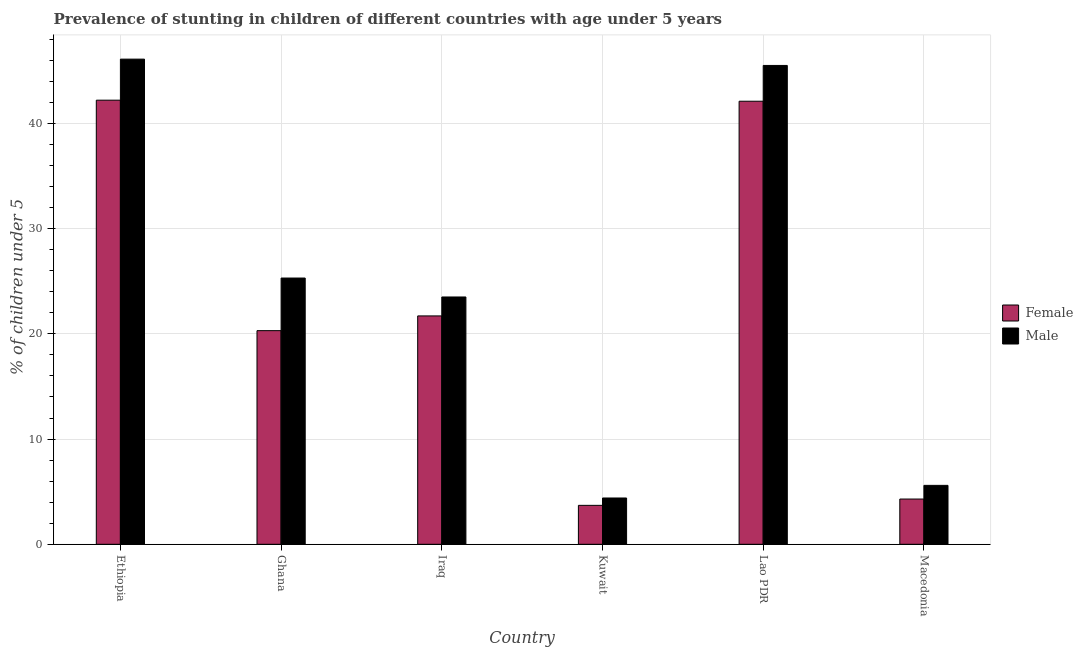How many different coloured bars are there?
Provide a short and direct response. 2. How many groups of bars are there?
Your answer should be very brief. 6. Are the number of bars per tick equal to the number of legend labels?
Your answer should be compact. Yes. Are the number of bars on each tick of the X-axis equal?
Your answer should be compact. Yes. How many bars are there on the 1st tick from the right?
Your answer should be very brief. 2. What is the percentage of stunted female children in Macedonia?
Give a very brief answer. 4.3. Across all countries, what is the maximum percentage of stunted male children?
Keep it short and to the point. 46.1. Across all countries, what is the minimum percentage of stunted female children?
Provide a short and direct response. 3.7. In which country was the percentage of stunted female children maximum?
Ensure brevity in your answer.  Ethiopia. In which country was the percentage of stunted female children minimum?
Give a very brief answer. Kuwait. What is the total percentage of stunted female children in the graph?
Ensure brevity in your answer.  134.3. What is the difference between the percentage of stunted male children in Ethiopia and that in Lao PDR?
Provide a succinct answer. 0.6. What is the difference between the percentage of stunted female children in Ghana and the percentage of stunted male children in Lao PDR?
Give a very brief answer. -25.2. What is the average percentage of stunted female children per country?
Keep it short and to the point. 22.38. What is the difference between the percentage of stunted male children and percentage of stunted female children in Iraq?
Offer a terse response. 1.8. In how many countries, is the percentage of stunted female children greater than 32 %?
Give a very brief answer. 2. What is the ratio of the percentage of stunted female children in Ethiopia to that in Kuwait?
Provide a succinct answer. 11.41. Is the difference between the percentage of stunted male children in Ethiopia and Macedonia greater than the difference between the percentage of stunted female children in Ethiopia and Macedonia?
Your answer should be very brief. Yes. What is the difference between the highest and the second highest percentage of stunted female children?
Your answer should be compact. 0.1. What is the difference between the highest and the lowest percentage of stunted female children?
Your answer should be very brief. 38.5. In how many countries, is the percentage of stunted female children greater than the average percentage of stunted female children taken over all countries?
Offer a very short reply. 2. Is the sum of the percentage of stunted male children in Ethiopia and Lao PDR greater than the maximum percentage of stunted female children across all countries?
Make the answer very short. Yes. What does the 1st bar from the right in Ghana represents?
Offer a very short reply. Male. How many bars are there?
Your answer should be compact. 12. What is the difference between two consecutive major ticks on the Y-axis?
Provide a succinct answer. 10. Does the graph contain any zero values?
Offer a terse response. No. Does the graph contain grids?
Your response must be concise. Yes. Where does the legend appear in the graph?
Keep it short and to the point. Center right. How many legend labels are there?
Give a very brief answer. 2. How are the legend labels stacked?
Provide a succinct answer. Vertical. What is the title of the graph?
Offer a very short reply. Prevalence of stunting in children of different countries with age under 5 years. Does "Lowest 10% of population" appear as one of the legend labels in the graph?
Give a very brief answer. No. What is the label or title of the Y-axis?
Your answer should be compact.  % of children under 5. What is the  % of children under 5 in Female in Ethiopia?
Offer a very short reply. 42.2. What is the  % of children under 5 of Male in Ethiopia?
Your response must be concise. 46.1. What is the  % of children under 5 of Female in Ghana?
Ensure brevity in your answer.  20.3. What is the  % of children under 5 in Male in Ghana?
Offer a terse response. 25.3. What is the  % of children under 5 in Female in Iraq?
Ensure brevity in your answer.  21.7. What is the  % of children under 5 of Female in Kuwait?
Your response must be concise. 3.7. What is the  % of children under 5 of Male in Kuwait?
Your answer should be compact. 4.4. What is the  % of children under 5 in Female in Lao PDR?
Provide a succinct answer. 42.1. What is the  % of children under 5 of Male in Lao PDR?
Ensure brevity in your answer.  45.5. What is the  % of children under 5 in Female in Macedonia?
Offer a very short reply. 4.3. What is the  % of children under 5 of Male in Macedonia?
Ensure brevity in your answer.  5.6. Across all countries, what is the maximum  % of children under 5 of Female?
Provide a short and direct response. 42.2. Across all countries, what is the maximum  % of children under 5 of Male?
Your answer should be very brief. 46.1. Across all countries, what is the minimum  % of children under 5 in Female?
Your response must be concise. 3.7. Across all countries, what is the minimum  % of children under 5 of Male?
Your answer should be very brief. 4.4. What is the total  % of children under 5 in Female in the graph?
Your answer should be very brief. 134.3. What is the total  % of children under 5 of Male in the graph?
Give a very brief answer. 150.4. What is the difference between the  % of children under 5 in Female in Ethiopia and that in Ghana?
Ensure brevity in your answer.  21.9. What is the difference between the  % of children under 5 of Male in Ethiopia and that in Ghana?
Your answer should be compact. 20.8. What is the difference between the  % of children under 5 of Male in Ethiopia and that in Iraq?
Your response must be concise. 22.6. What is the difference between the  % of children under 5 of Female in Ethiopia and that in Kuwait?
Give a very brief answer. 38.5. What is the difference between the  % of children under 5 of Male in Ethiopia and that in Kuwait?
Provide a succinct answer. 41.7. What is the difference between the  % of children under 5 in Female in Ethiopia and that in Lao PDR?
Provide a short and direct response. 0.1. What is the difference between the  % of children under 5 in Male in Ethiopia and that in Lao PDR?
Ensure brevity in your answer.  0.6. What is the difference between the  % of children under 5 of Female in Ethiopia and that in Macedonia?
Your response must be concise. 37.9. What is the difference between the  % of children under 5 of Male in Ethiopia and that in Macedonia?
Give a very brief answer. 40.5. What is the difference between the  % of children under 5 of Female in Ghana and that in Iraq?
Your answer should be very brief. -1.4. What is the difference between the  % of children under 5 in Male in Ghana and that in Iraq?
Give a very brief answer. 1.8. What is the difference between the  % of children under 5 in Female in Ghana and that in Kuwait?
Offer a very short reply. 16.6. What is the difference between the  % of children under 5 in Male in Ghana and that in Kuwait?
Offer a terse response. 20.9. What is the difference between the  % of children under 5 in Female in Ghana and that in Lao PDR?
Offer a terse response. -21.8. What is the difference between the  % of children under 5 of Male in Ghana and that in Lao PDR?
Offer a very short reply. -20.2. What is the difference between the  % of children under 5 of Female in Iraq and that in Kuwait?
Provide a short and direct response. 18. What is the difference between the  % of children under 5 of Female in Iraq and that in Lao PDR?
Offer a terse response. -20.4. What is the difference between the  % of children under 5 in Male in Iraq and that in Lao PDR?
Your response must be concise. -22. What is the difference between the  % of children under 5 in Female in Kuwait and that in Lao PDR?
Ensure brevity in your answer.  -38.4. What is the difference between the  % of children under 5 in Male in Kuwait and that in Lao PDR?
Offer a very short reply. -41.1. What is the difference between the  % of children under 5 of Male in Kuwait and that in Macedonia?
Give a very brief answer. -1.2. What is the difference between the  % of children under 5 in Female in Lao PDR and that in Macedonia?
Your answer should be compact. 37.8. What is the difference between the  % of children under 5 in Male in Lao PDR and that in Macedonia?
Make the answer very short. 39.9. What is the difference between the  % of children under 5 of Female in Ethiopia and the  % of children under 5 of Male in Iraq?
Offer a terse response. 18.7. What is the difference between the  % of children under 5 of Female in Ethiopia and the  % of children under 5 of Male in Kuwait?
Give a very brief answer. 37.8. What is the difference between the  % of children under 5 of Female in Ethiopia and the  % of children under 5 of Male in Macedonia?
Keep it short and to the point. 36.6. What is the difference between the  % of children under 5 in Female in Ghana and the  % of children under 5 in Male in Iraq?
Your response must be concise. -3.2. What is the difference between the  % of children under 5 of Female in Ghana and the  % of children under 5 of Male in Kuwait?
Provide a succinct answer. 15.9. What is the difference between the  % of children under 5 in Female in Ghana and the  % of children under 5 in Male in Lao PDR?
Make the answer very short. -25.2. What is the difference between the  % of children under 5 in Female in Iraq and the  % of children under 5 in Male in Kuwait?
Offer a terse response. 17.3. What is the difference between the  % of children under 5 in Female in Iraq and the  % of children under 5 in Male in Lao PDR?
Give a very brief answer. -23.8. What is the difference between the  % of children under 5 of Female in Iraq and the  % of children under 5 of Male in Macedonia?
Provide a short and direct response. 16.1. What is the difference between the  % of children under 5 of Female in Kuwait and the  % of children under 5 of Male in Lao PDR?
Give a very brief answer. -41.8. What is the difference between the  % of children under 5 of Female in Kuwait and the  % of children under 5 of Male in Macedonia?
Offer a terse response. -1.9. What is the difference between the  % of children under 5 of Female in Lao PDR and the  % of children under 5 of Male in Macedonia?
Ensure brevity in your answer.  36.5. What is the average  % of children under 5 of Female per country?
Offer a terse response. 22.38. What is the average  % of children under 5 of Male per country?
Provide a short and direct response. 25.07. What is the ratio of the  % of children under 5 in Female in Ethiopia to that in Ghana?
Keep it short and to the point. 2.08. What is the ratio of the  % of children under 5 of Male in Ethiopia to that in Ghana?
Give a very brief answer. 1.82. What is the ratio of the  % of children under 5 of Female in Ethiopia to that in Iraq?
Your answer should be very brief. 1.94. What is the ratio of the  % of children under 5 of Male in Ethiopia to that in Iraq?
Offer a terse response. 1.96. What is the ratio of the  % of children under 5 in Female in Ethiopia to that in Kuwait?
Your response must be concise. 11.41. What is the ratio of the  % of children under 5 in Male in Ethiopia to that in Kuwait?
Provide a short and direct response. 10.48. What is the ratio of the  % of children under 5 of Male in Ethiopia to that in Lao PDR?
Offer a terse response. 1.01. What is the ratio of the  % of children under 5 of Female in Ethiopia to that in Macedonia?
Offer a very short reply. 9.81. What is the ratio of the  % of children under 5 in Male in Ethiopia to that in Macedonia?
Your response must be concise. 8.23. What is the ratio of the  % of children under 5 of Female in Ghana to that in Iraq?
Offer a terse response. 0.94. What is the ratio of the  % of children under 5 in Male in Ghana to that in Iraq?
Offer a very short reply. 1.08. What is the ratio of the  % of children under 5 in Female in Ghana to that in Kuwait?
Provide a short and direct response. 5.49. What is the ratio of the  % of children under 5 in Male in Ghana to that in Kuwait?
Offer a very short reply. 5.75. What is the ratio of the  % of children under 5 in Female in Ghana to that in Lao PDR?
Give a very brief answer. 0.48. What is the ratio of the  % of children under 5 in Male in Ghana to that in Lao PDR?
Provide a succinct answer. 0.56. What is the ratio of the  % of children under 5 in Female in Ghana to that in Macedonia?
Give a very brief answer. 4.72. What is the ratio of the  % of children under 5 in Male in Ghana to that in Macedonia?
Provide a short and direct response. 4.52. What is the ratio of the  % of children under 5 in Female in Iraq to that in Kuwait?
Your answer should be very brief. 5.86. What is the ratio of the  % of children under 5 in Male in Iraq to that in Kuwait?
Keep it short and to the point. 5.34. What is the ratio of the  % of children under 5 of Female in Iraq to that in Lao PDR?
Provide a succinct answer. 0.52. What is the ratio of the  % of children under 5 in Male in Iraq to that in Lao PDR?
Make the answer very short. 0.52. What is the ratio of the  % of children under 5 in Female in Iraq to that in Macedonia?
Offer a very short reply. 5.05. What is the ratio of the  % of children under 5 of Male in Iraq to that in Macedonia?
Give a very brief answer. 4.2. What is the ratio of the  % of children under 5 of Female in Kuwait to that in Lao PDR?
Your answer should be very brief. 0.09. What is the ratio of the  % of children under 5 of Male in Kuwait to that in Lao PDR?
Make the answer very short. 0.1. What is the ratio of the  % of children under 5 in Female in Kuwait to that in Macedonia?
Ensure brevity in your answer.  0.86. What is the ratio of the  % of children under 5 in Male in Kuwait to that in Macedonia?
Offer a very short reply. 0.79. What is the ratio of the  % of children under 5 of Female in Lao PDR to that in Macedonia?
Give a very brief answer. 9.79. What is the ratio of the  % of children under 5 in Male in Lao PDR to that in Macedonia?
Your answer should be compact. 8.12. What is the difference between the highest and the second highest  % of children under 5 of Female?
Make the answer very short. 0.1. What is the difference between the highest and the second highest  % of children under 5 of Male?
Keep it short and to the point. 0.6. What is the difference between the highest and the lowest  % of children under 5 in Female?
Your answer should be very brief. 38.5. What is the difference between the highest and the lowest  % of children under 5 in Male?
Ensure brevity in your answer.  41.7. 